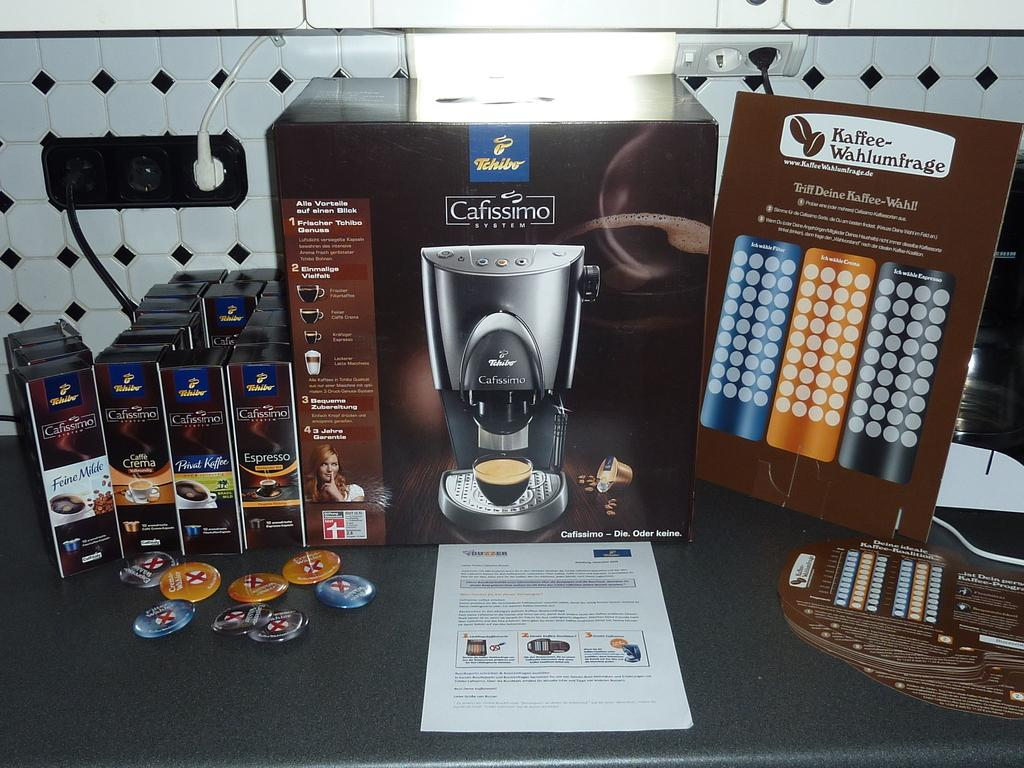Provide a one-sentence caption for the provided image. Cafissimo System machine for making coffee and list of products on that machine. 